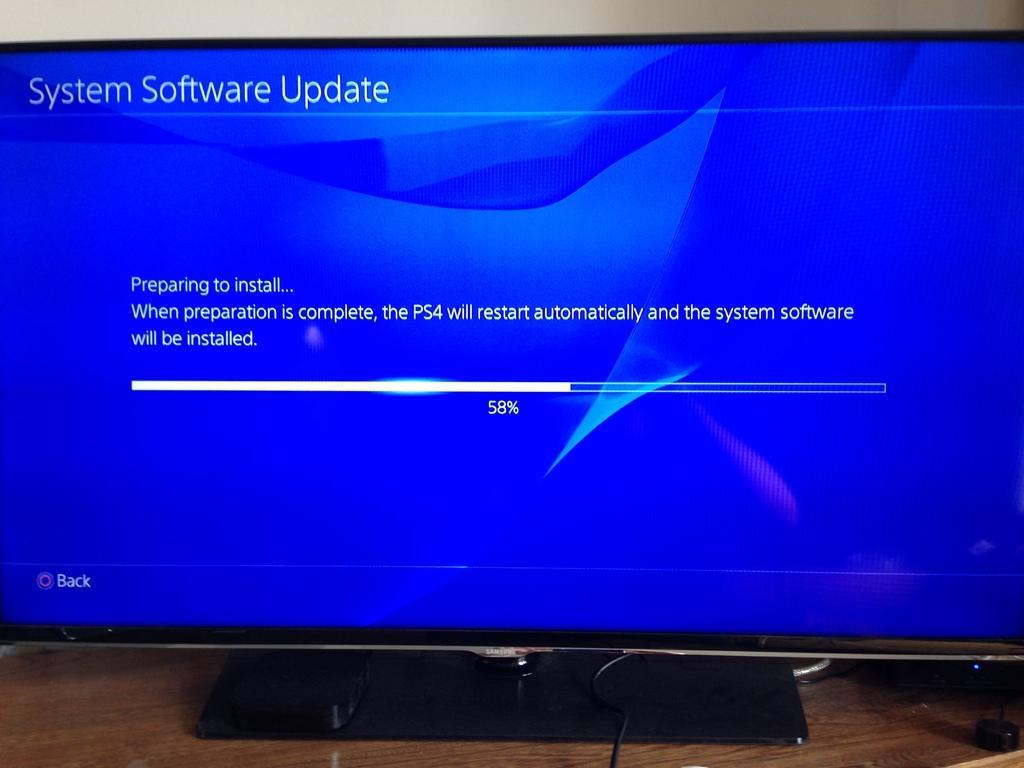Could you give a brief overview of what you see in this image? In this image I can see the system on the brown color table. I can see the screen is in blue color and there is a text on it. In the back I can see the white wall. 